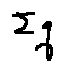<formula> <loc_0><loc_0><loc_500><loc_500>\sum q</formula> 